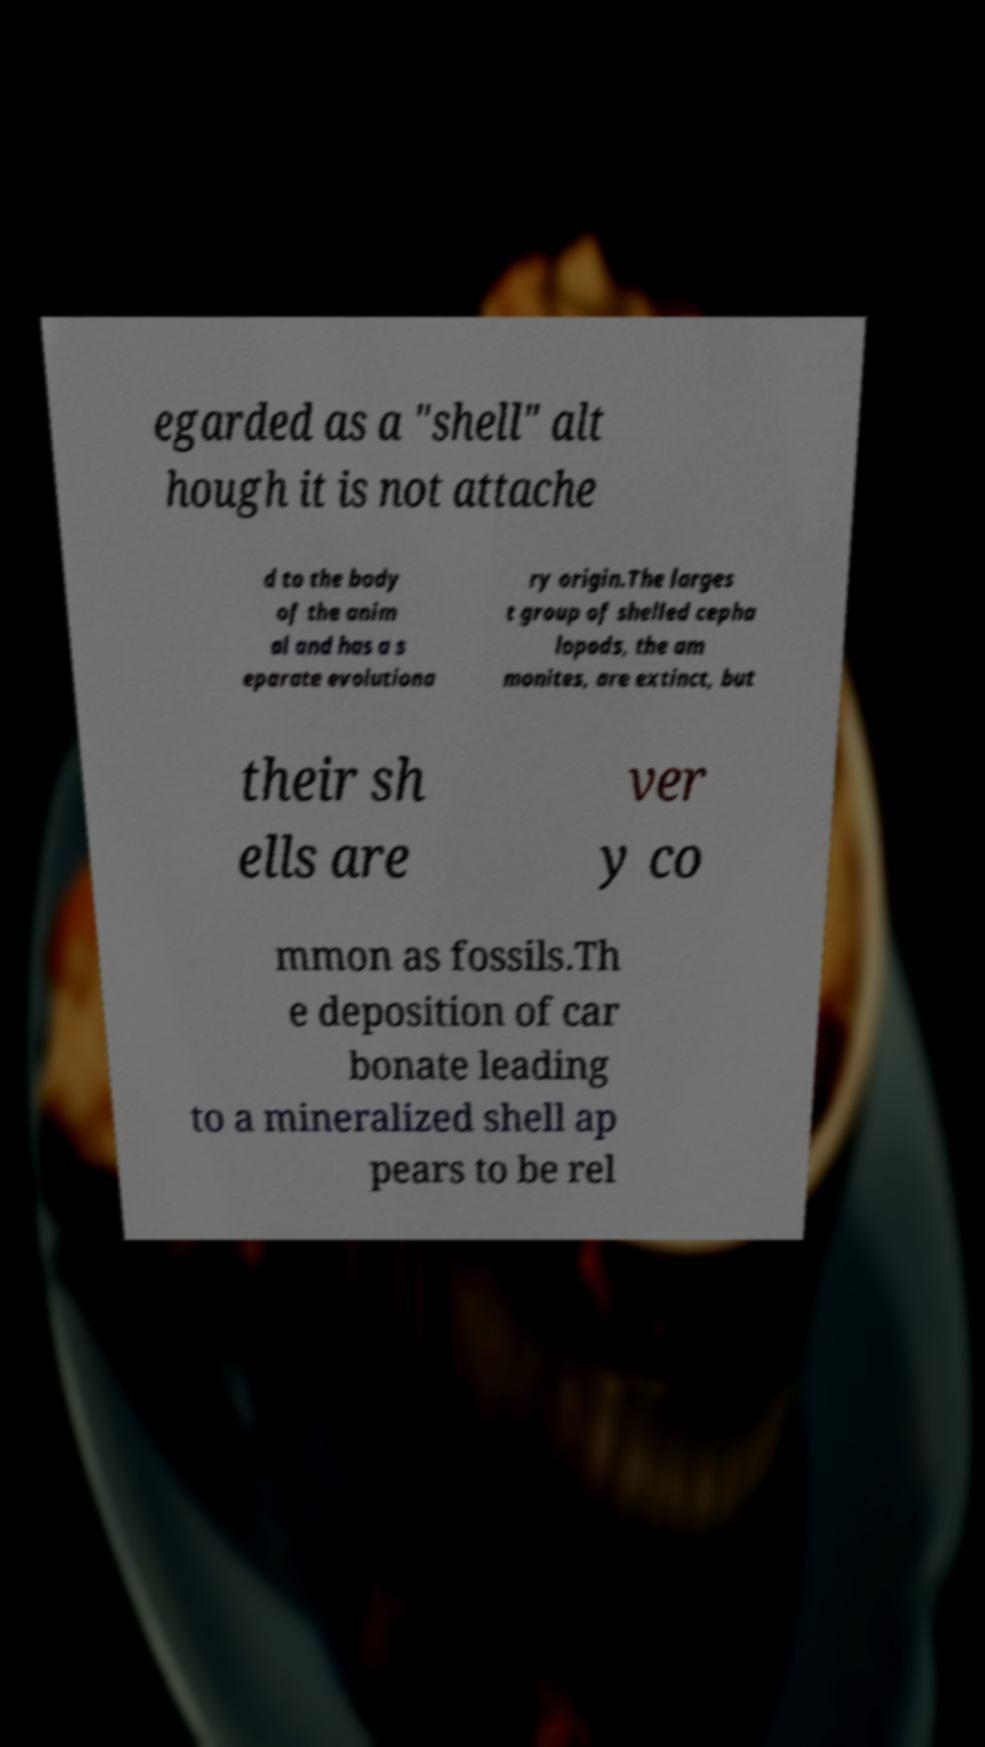Please read and relay the text visible in this image. What does it say? egarded as a "shell" alt hough it is not attache d to the body of the anim al and has a s eparate evolutiona ry origin.The larges t group of shelled cepha lopods, the am monites, are extinct, but their sh ells are ver y co mmon as fossils.Th e deposition of car bonate leading to a mineralized shell ap pears to be rel 